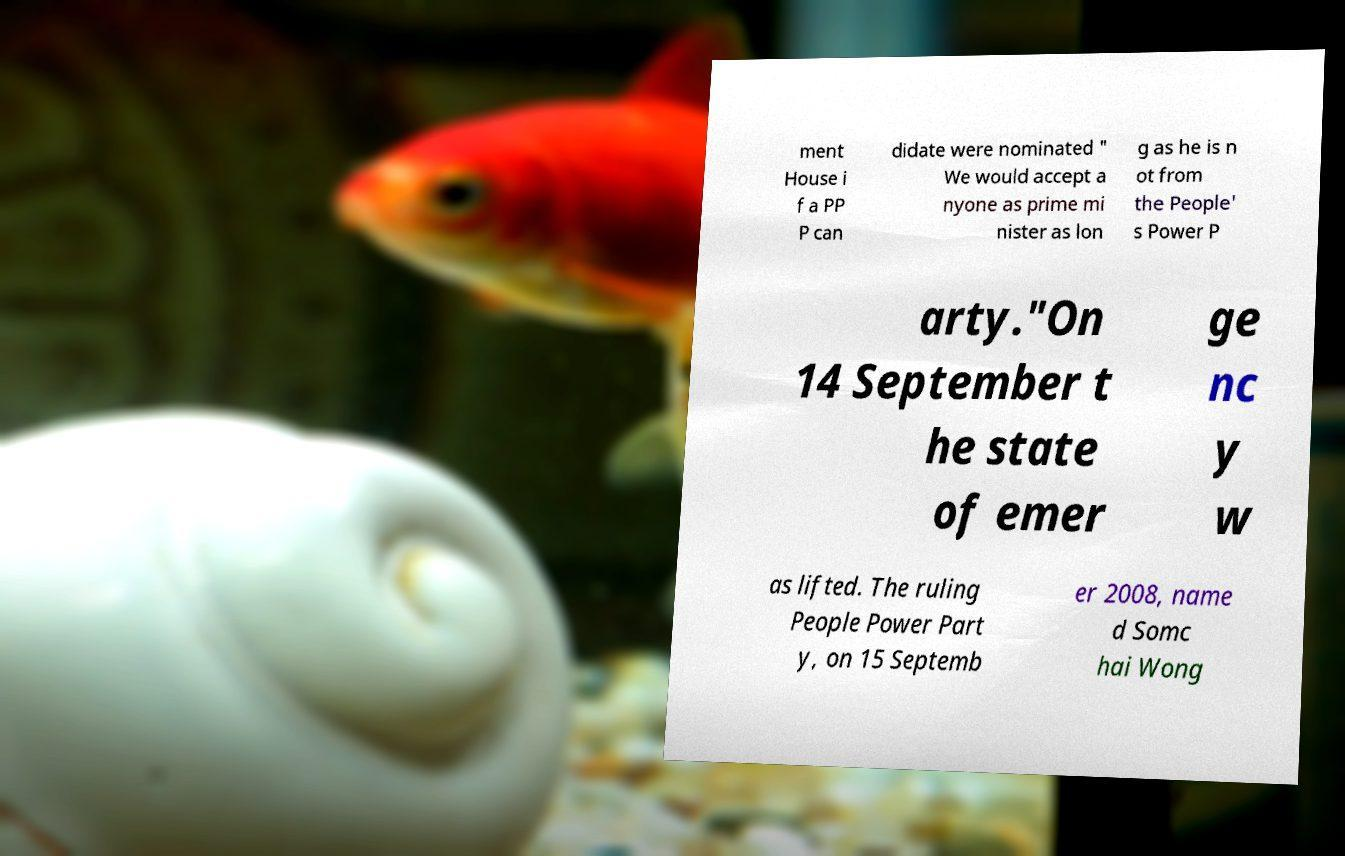Please read and relay the text visible in this image. What does it say? ment House i f a PP P can didate were nominated " We would accept a nyone as prime mi nister as lon g as he is n ot from the People' s Power P arty."On 14 September t he state of emer ge nc y w as lifted. The ruling People Power Part y, on 15 Septemb er 2008, name d Somc hai Wong 